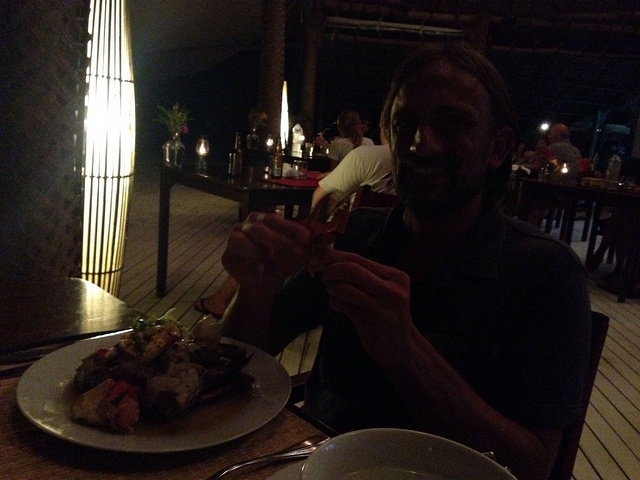Describe the objects in this image and their specific colors. I can see people in black, maroon, and gray tones, dining table in black and gray tones, dining table in black, maroon, and gray tones, cup in black and gray tones, and bowl in black and gray tones in this image. 